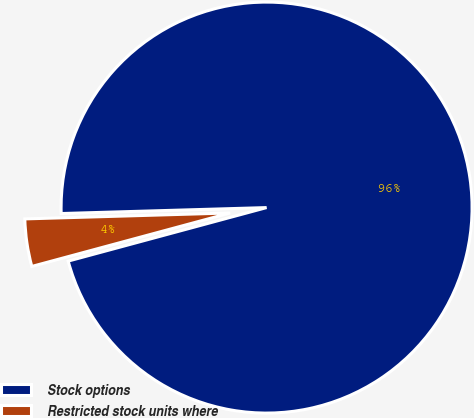Convert chart. <chart><loc_0><loc_0><loc_500><loc_500><pie_chart><fcel>Stock options<fcel>Restricted stock units where<nl><fcel>96.27%<fcel>3.73%<nl></chart> 